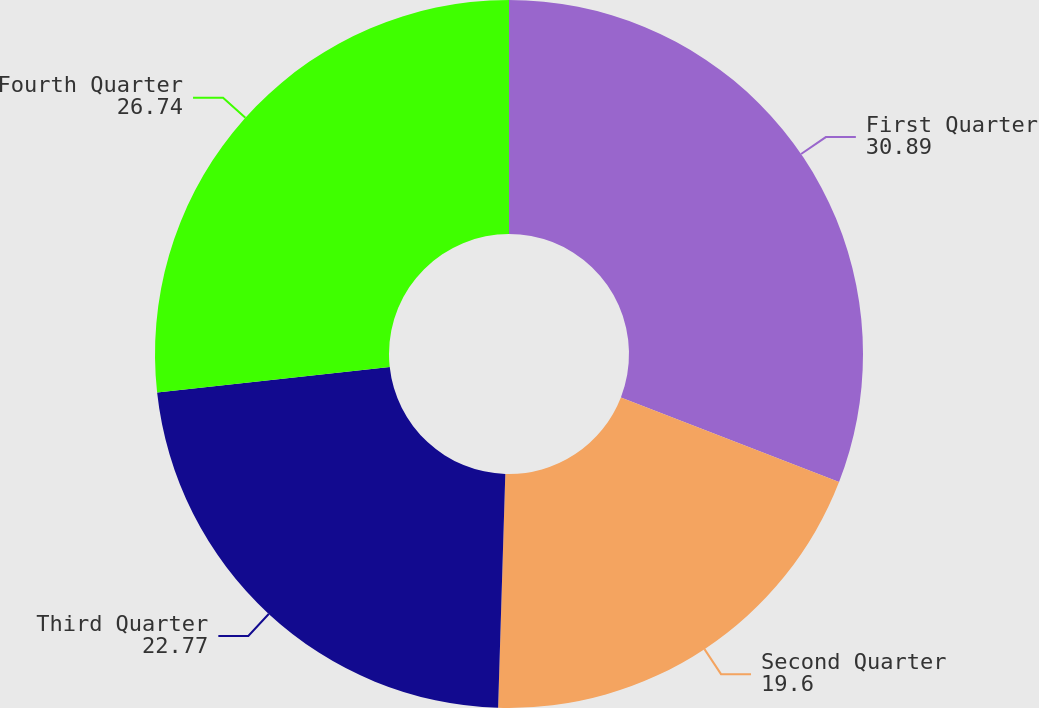Convert chart to OTSL. <chart><loc_0><loc_0><loc_500><loc_500><pie_chart><fcel>First Quarter<fcel>Second Quarter<fcel>Third Quarter<fcel>Fourth Quarter<nl><fcel>30.89%<fcel>19.6%<fcel>22.77%<fcel>26.74%<nl></chart> 